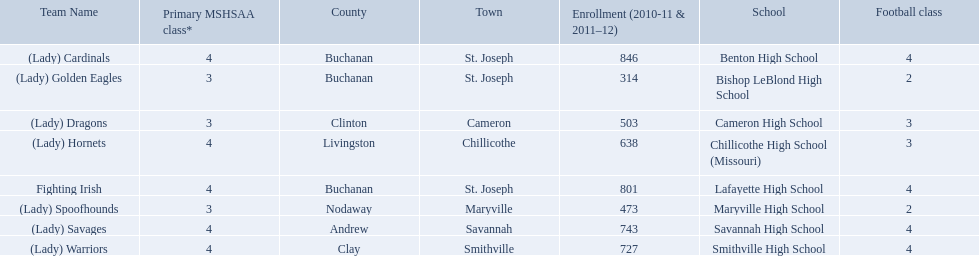What are the three schools in the town of st. joseph? St. Joseph, St. Joseph, St. Joseph. Of the three schools in st. joseph which school's team name does not depict a type of animal? Lafayette High School. 